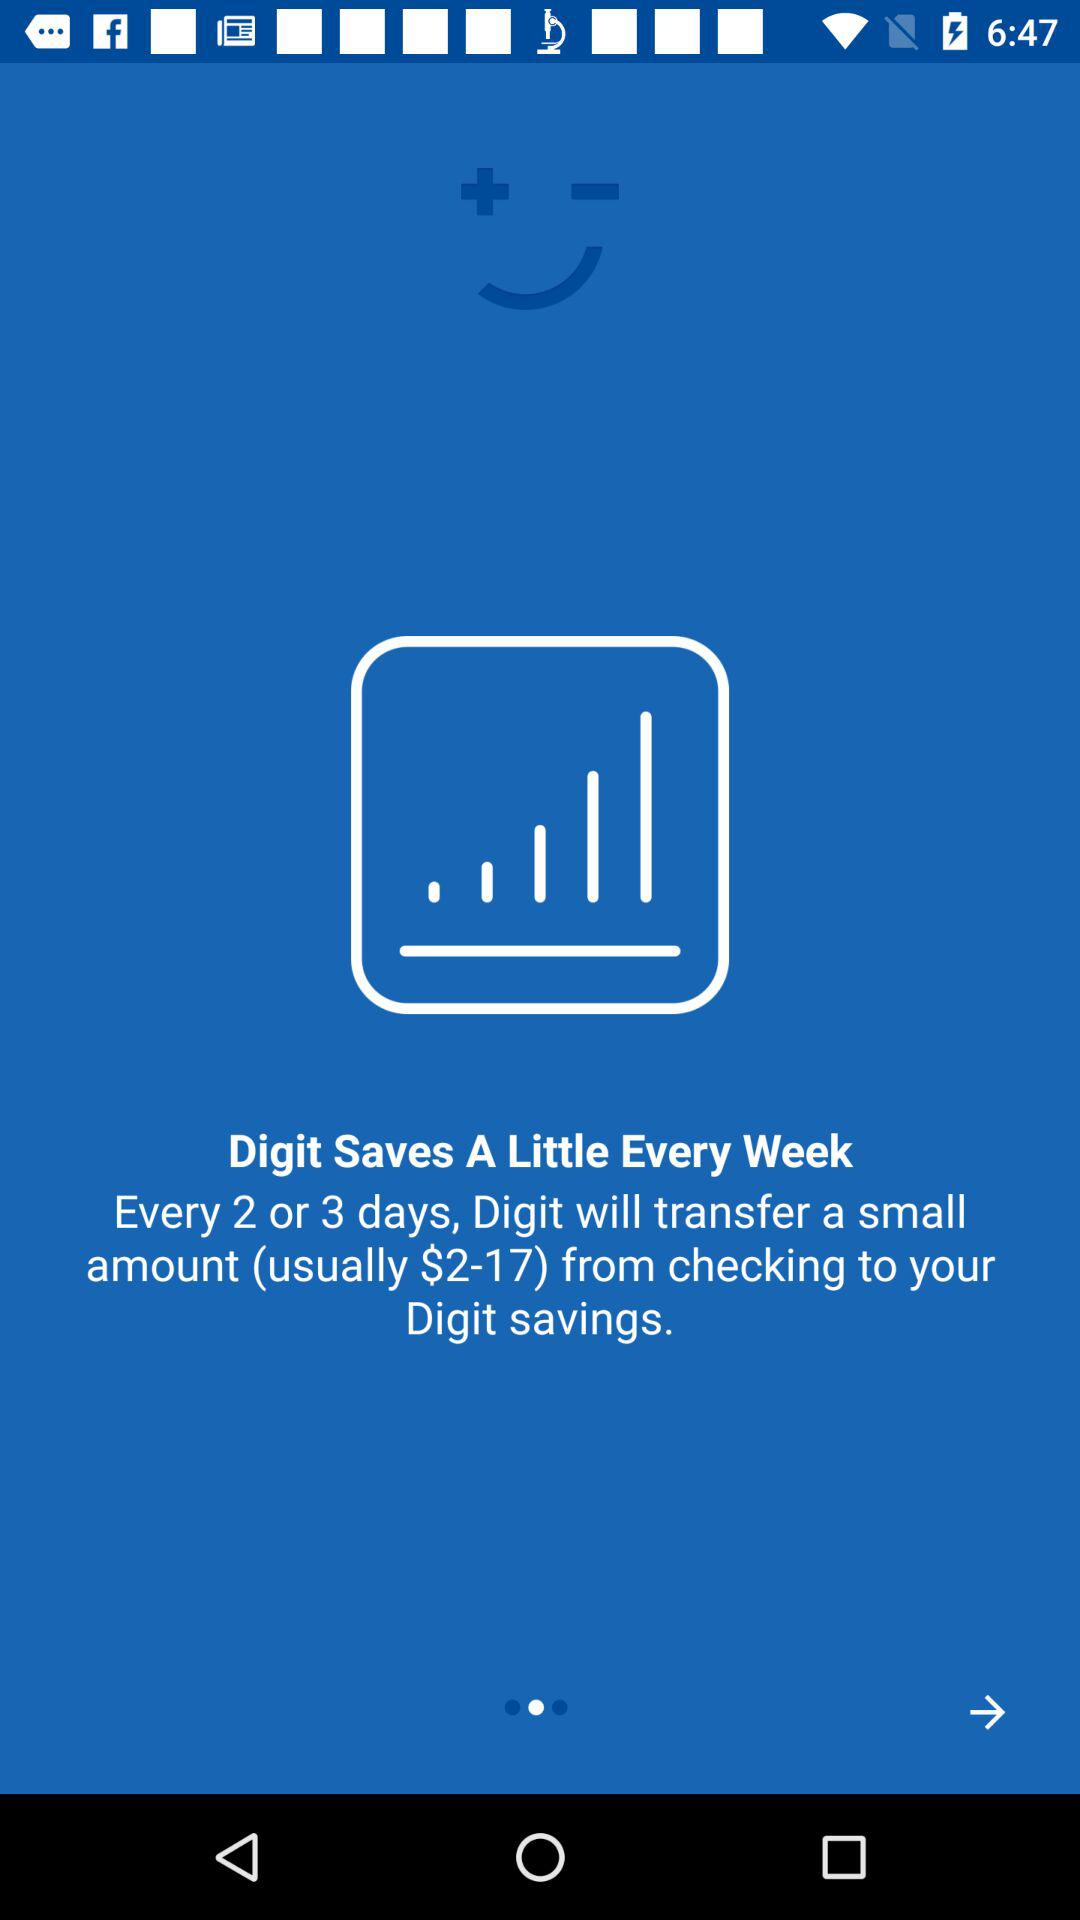What amount will "Digit" send to "Digit" savings? "Digit" will transfer a small amount (usually $2-17) from checking to your "Digit" savings. 